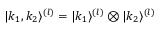Convert formula to latex. <formula><loc_0><loc_0><loc_500><loc_500>\begin{array} { r } { | k _ { 1 } , k _ { 2 } \rangle ^ { ( l ) } = | k _ { 1 } \rangle ^ { ( l ) } \otimes | k _ { 2 } \rangle ^ { ( l ) } } \end{array}</formula> 